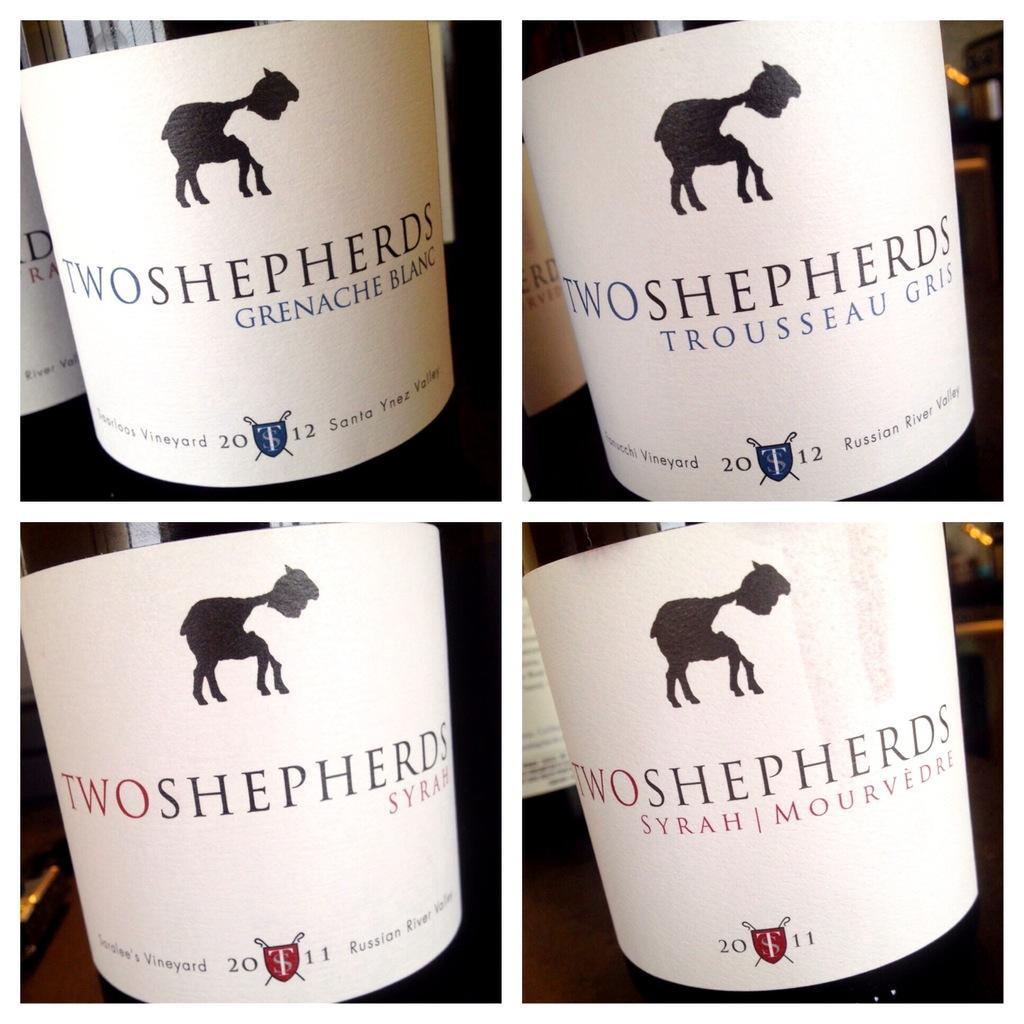Can you describe this image briefly? In this image we can see four pictures in which we can see a label on the bottle which is placed on the surface. In the background, we can see a few more bottles with labels. 